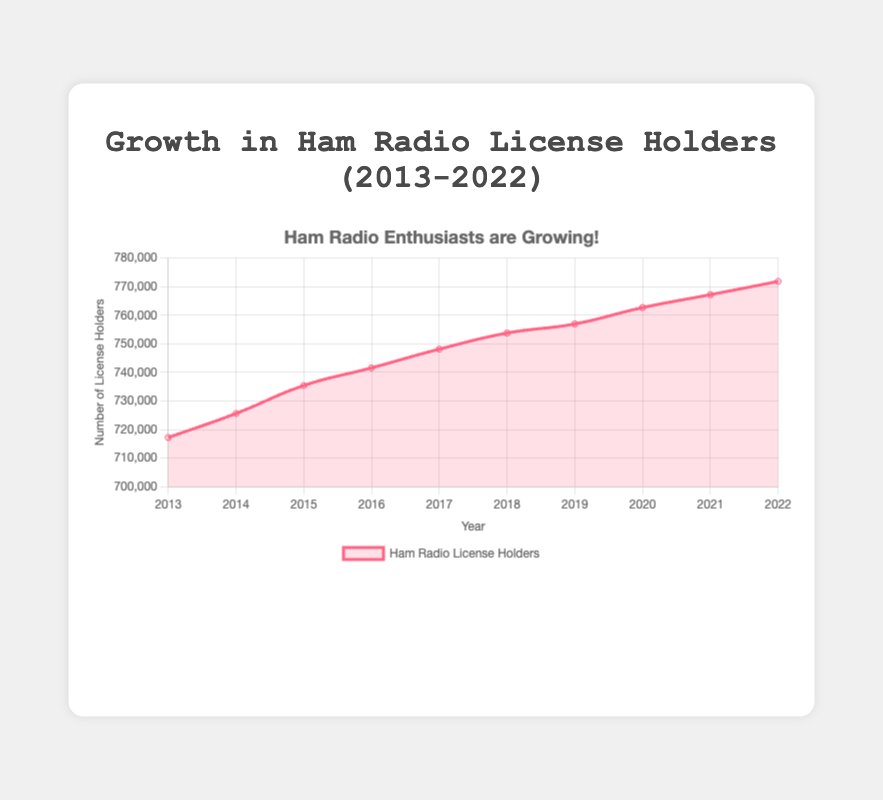What is the average number of ham radio license holders from 2013 to 2022? To calculate the average, sum the number of license holders for each year (717201 + 725617 + 735405 + 741584 + 748136 + 753760 + 756958 + 762673 + 767200 + 771828) = 7480362. Then divide the total by the number of years (10). The average is 7480362 / 10 = 748036.2
Answer: 748036.2 In which year was the increase in ham radio license holders the largest compared to the previous year? Analyze the year-on-year differences: 2014-2013 = 8416, 2015-2014 = 9788, 2016-2015 = 6179, 2017-2016 = 6552, 2018-2017 = 5624, 2019-2018 = 3198, 2020-2019 = 5715, 2021-2020 = 4527, 2022-2021 = 4628. The largest increase is from 2014 to 2015
Answer: 2015 What is the overall growth in the number of ham radio license holders from 2013 to 2022? Subtract the number of license holders in 2013 from the number in 2022 (771828 - 717201)
Answer: 54627 Which year experienced the smallest increase in the number of ham radio license holders compared to the previous year? Analyze the year-on-year differences: 2014-2013 = 8416, 2015-2014 = 9788, 2016-2015 = 6179, 2017-2016 = 6552, 2018-2017 = 5624, 2019-2018 = 3198, 2020-2019 = 5715, 2021-2020 = 4527, 2022-2021 = 4628. The smallest increase is from 2018 to 2019
Answer: 2019 By how much did the number of ham radio license holders grow from 2016 to 2020? Subtract the number of license holders in 2016 from the number in 2020 (762673 - 741584)
Answer: 21089 Which year had the highest number of ham radio license holders? Look at the data points on the graph and identify the year with the highest value. 2022 has the highest value of 771828
Answer: 2022 What is the trend of the number of ham radio license holders over the decade shown in the chart? Observe the general direction of the line in the graph from 2013 to 2022. The number of license holders increases steadily over the decade
Answer: Increasing steadily What was the percentage growth in the number of ham radio license holders from 2013 to 2022? Calculate the percentage using the formula [(final value - initial value) / initial value] * 100. Here it is [(771828 - 717201) / 717201] * 100 ≈ 7.62%
Answer: 7.62 Which years do the number of ham radio license holders surpass 750,000? Identify the years where the data points are above the 750,000 mark: 2018 (753760), 2019 (756958), 2020 (762673), 2021 (767200), 2022 (771828)
Answer: 2018, 2019, 2020, 2021, 2022 How consistent is the annual growth of ham radio license holders over the decade? Examine the differences in the number of license holders each year: 8416, 9788, 6179, 6552, 5624, 3198, 5715, 4527, 4628. The differences slightly fluctuate but generally show a modest and consistent growth pattern in most years
Answer: Modest and consistent 